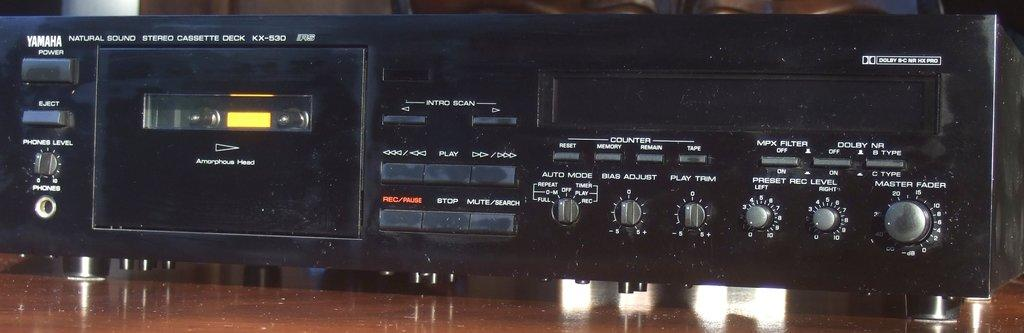<image>
Provide a brief description of the given image. An older Yamaha cassette tape that works with a larger home console unit. 